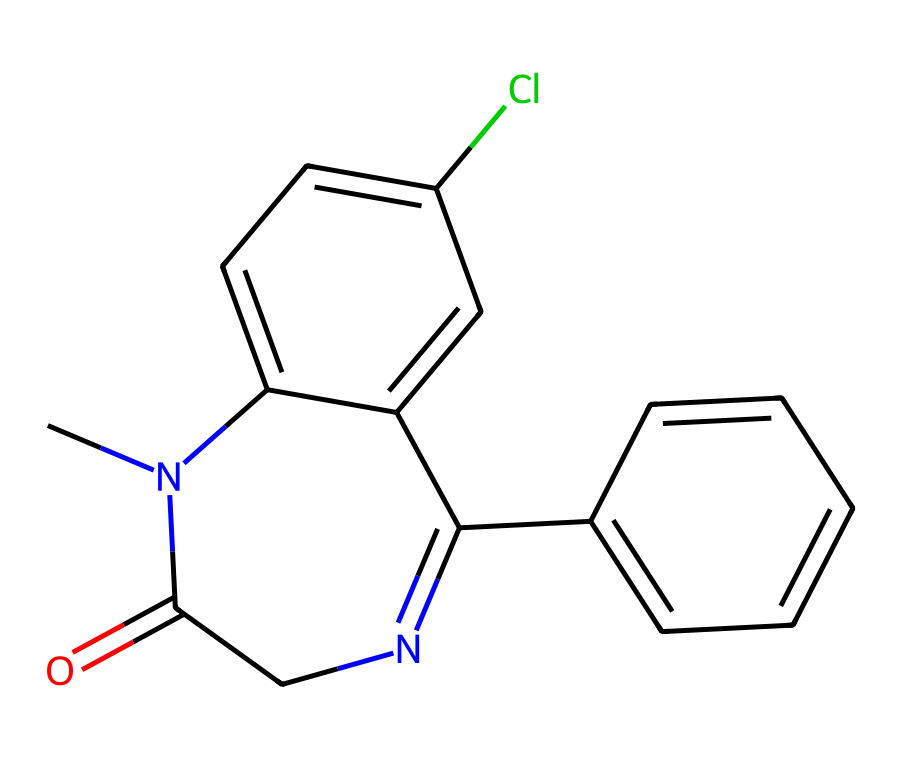How many carbon atoms are in this chemical? In the provided SMILES representation, count the 'C' characters, which represent carbon atoms. There are 14 occurrences of 'C'.
Answer: 14 What type of isomerism can occur in this chemical structure? The presence of the double bonds between atoms in the cyclic structure suggests geometric isomerism (cis/trans). The specific arrangement can vary at the double bonds.
Answer: geometric Is this chemical a solid, liquid, or gas at room temperature? Considering the structure consists of aromatic rings and a nitrogen-containing five-membered ring, it is likely to be a solid at room temperature due to higher molecular mass and intermolecular forces.
Answer: solid How many chlorine atoms are present in this chemical? In the SMILES, there is one 'Cl' notation, indicating the presence of a single chlorine atom in the structure.
Answer: 1 What functional groups are present in this chemical? The molecule contains an amide (CN1C(=O)) and aryl groups (related to the benzene rings), which are characteristic functional groups that influence its reactivity and properties.
Answer: amide and aryl Can this chemical produce geometric isomers? Yes, because it contains a double bond between carbons in a ring, which allows for cis and trans arrangements, indicating the potential for geometric isomers.
Answer: yes What is the basic structure type of this chemical? The main components include a nitrogen-containing five-membered ring and a phenyl ring indicating that it is a bicyclic compound.
Answer: bicyclic 